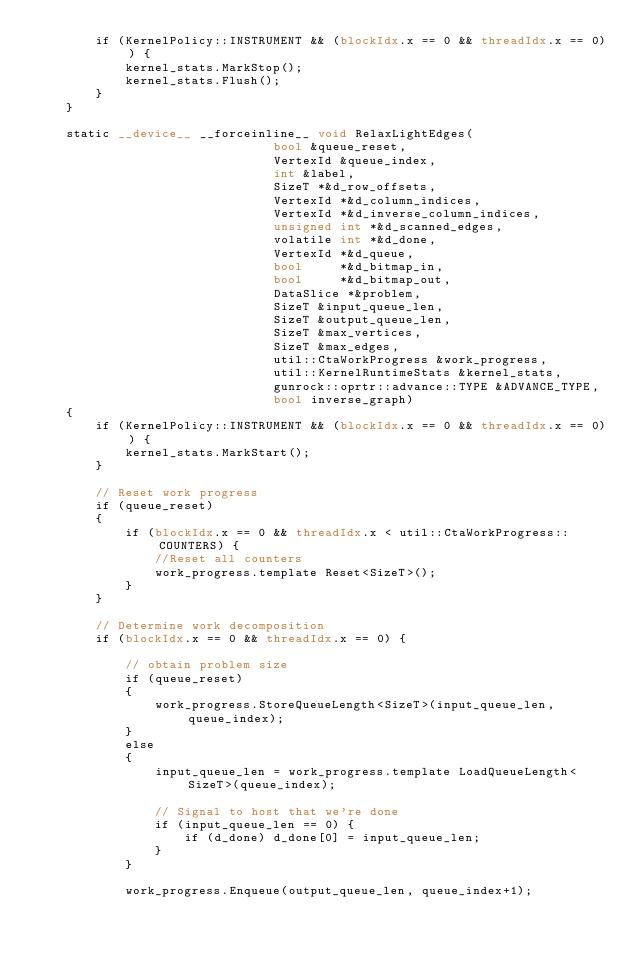<code> <loc_0><loc_0><loc_500><loc_500><_Cuda_>        if (KernelPolicy::INSTRUMENT && (blockIdx.x == 0 && threadIdx.x == 0)) {
            kernel_stats.MarkStop();
            kernel_stats.Flush();
        }
    }

    static __device__ __forceinline__ void RelaxLightEdges(
                                bool &queue_reset,
                                VertexId &queue_index,
                                int &label,
                                SizeT *&d_row_offsets,
                                VertexId *&d_column_indices,
                                VertexId *&d_inverse_column_indices,
                                unsigned int *&d_scanned_edges,
                                volatile int *&d_done,
                                VertexId *&d_queue,
                                bool     *&d_bitmap_in,
                                bool     *&d_bitmap_out,
                                DataSlice *&problem,
                                SizeT &input_queue_len,
                                SizeT &output_queue_len,
                                SizeT &max_vertices,
                                SizeT &max_edges,
                                util::CtaWorkProgress &work_progress,
                                util::KernelRuntimeStats &kernel_stats,
                                gunrock::oprtr::advance::TYPE &ADVANCE_TYPE,
                                bool inverse_graph)
    {
        if (KernelPolicy::INSTRUMENT && (blockIdx.x == 0 && threadIdx.x == 0)) {
            kernel_stats.MarkStart();
        }

        // Reset work progress
        if (queue_reset)
        {
            if (blockIdx.x == 0 && threadIdx.x < util::CtaWorkProgress::COUNTERS) {
                //Reset all counters
                work_progress.template Reset<SizeT>();
            }
        }

        // Determine work decomposition
        if (blockIdx.x == 0 && threadIdx.x == 0) {

            // obtain problem size
            if (queue_reset)
            {
                work_progress.StoreQueueLength<SizeT>(input_queue_len, queue_index);
            }
            else
            {
                input_queue_len = work_progress.template LoadQueueLength<SizeT>(queue_index);
                
                // Signal to host that we're done
                if (input_queue_len == 0) {
                    if (d_done) d_done[0] = input_queue_len;
                }
            }

            work_progress.Enqueue(output_queue_len, queue_index+1);
</code> 